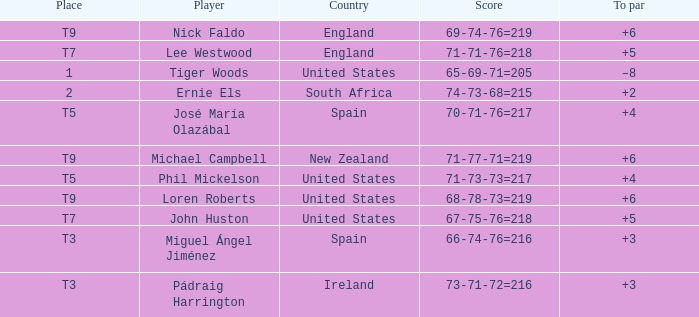What is Player, when Country is "England", and when Place is "T7"? Lee Westwood. 